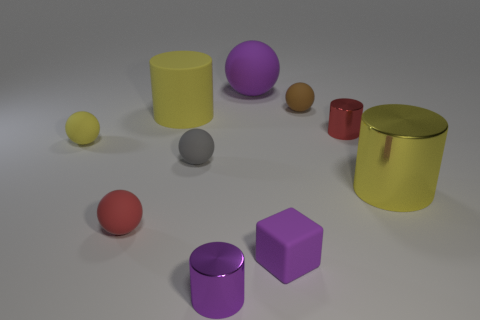Subtract all yellow matte cylinders. How many cylinders are left? 3 Subtract all gray spheres. How many spheres are left? 4 Subtract 3 balls. How many balls are left? 2 Subtract all green spheres. Subtract all gray cylinders. How many spheres are left? 5 Subtract all cubes. How many objects are left? 9 Subtract all large green metal balls. Subtract all small shiny things. How many objects are left? 8 Add 2 yellow rubber objects. How many yellow rubber objects are left? 4 Add 10 big cubes. How many big cubes exist? 10 Subtract 0 green cylinders. How many objects are left? 10 